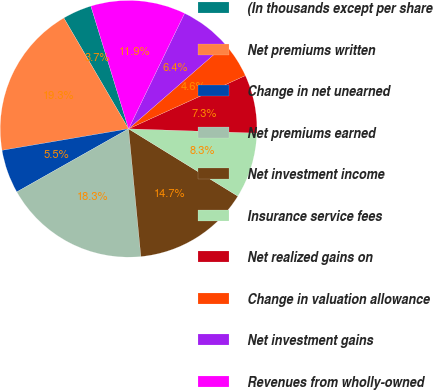<chart> <loc_0><loc_0><loc_500><loc_500><pie_chart><fcel>(In thousands except per share<fcel>Net premiums written<fcel>Change in net unearned<fcel>Net premiums earned<fcel>Net investment income<fcel>Insurance service fees<fcel>Net realized gains on<fcel>Change in valuation allowance<fcel>Net investment gains<fcel>Revenues from wholly-owned<nl><fcel>3.67%<fcel>19.27%<fcel>5.5%<fcel>18.35%<fcel>14.68%<fcel>8.26%<fcel>7.34%<fcel>4.59%<fcel>6.42%<fcel>11.93%<nl></chart> 